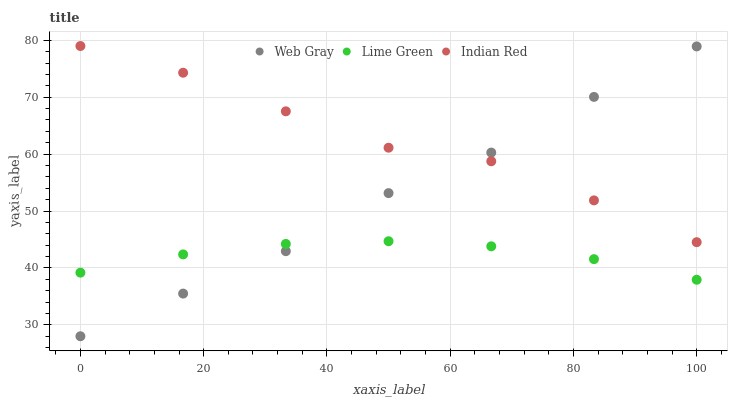Does Lime Green have the minimum area under the curve?
Answer yes or no. Yes. Does Indian Red have the maximum area under the curve?
Answer yes or no. Yes. Does Indian Red have the minimum area under the curve?
Answer yes or no. No. Does Lime Green have the maximum area under the curve?
Answer yes or no. No. Is Lime Green the smoothest?
Answer yes or no. Yes. Is Indian Red the roughest?
Answer yes or no. Yes. Is Indian Red the smoothest?
Answer yes or no. No. Is Lime Green the roughest?
Answer yes or no. No. Does Web Gray have the lowest value?
Answer yes or no. Yes. Does Lime Green have the lowest value?
Answer yes or no. No. Does Indian Red have the highest value?
Answer yes or no. Yes. Does Lime Green have the highest value?
Answer yes or no. No. Is Lime Green less than Indian Red?
Answer yes or no. Yes. Is Indian Red greater than Lime Green?
Answer yes or no. Yes. Does Indian Red intersect Web Gray?
Answer yes or no. Yes. Is Indian Red less than Web Gray?
Answer yes or no. No. Is Indian Red greater than Web Gray?
Answer yes or no. No. Does Lime Green intersect Indian Red?
Answer yes or no. No. 